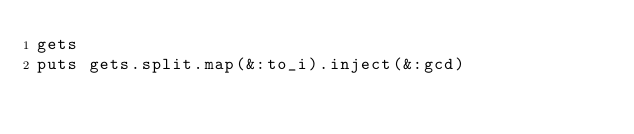Convert code to text. <code><loc_0><loc_0><loc_500><loc_500><_Ruby_>gets
puts gets.split.map(&:to_i).inject(&:gcd)
</code> 